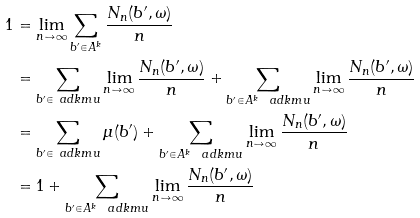Convert formula to latex. <formula><loc_0><loc_0><loc_500><loc_500>1 & = \lim _ { n \to \infty } \sum _ { b ^ { \prime } \in A ^ { k } } \frac { N _ { n } ( b ^ { \prime } , \omega ) } n \\ & = \sum _ { b ^ { \prime } \in \ a d k m u } \lim _ { n \to \infty } \frac { N _ { n } ( b ^ { \prime } , \omega ) } { n } + \sum _ { b ^ { \prime } \in A ^ { k } \ \ a d k m u } \lim _ { n \to \infty } \frac { N _ { n } ( b ^ { \prime } , \omega ) } { n } \\ & = \sum _ { b ^ { \prime } \in \ a d k m u } \mu ( b ^ { \prime } ) + \sum _ { b ^ { \prime } \in A ^ { k } \ \ a d k m u } \lim _ { n \to \infty } \frac { N _ { n } ( b ^ { \prime } , \omega ) } { n } \\ & = 1 + \sum _ { b ^ { \prime } \in A ^ { k } \ \ a d k m u } \lim _ { n \to \infty } \frac { N _ { n } ( b ^ { \prime } , \omega ) } { n }</formula> 